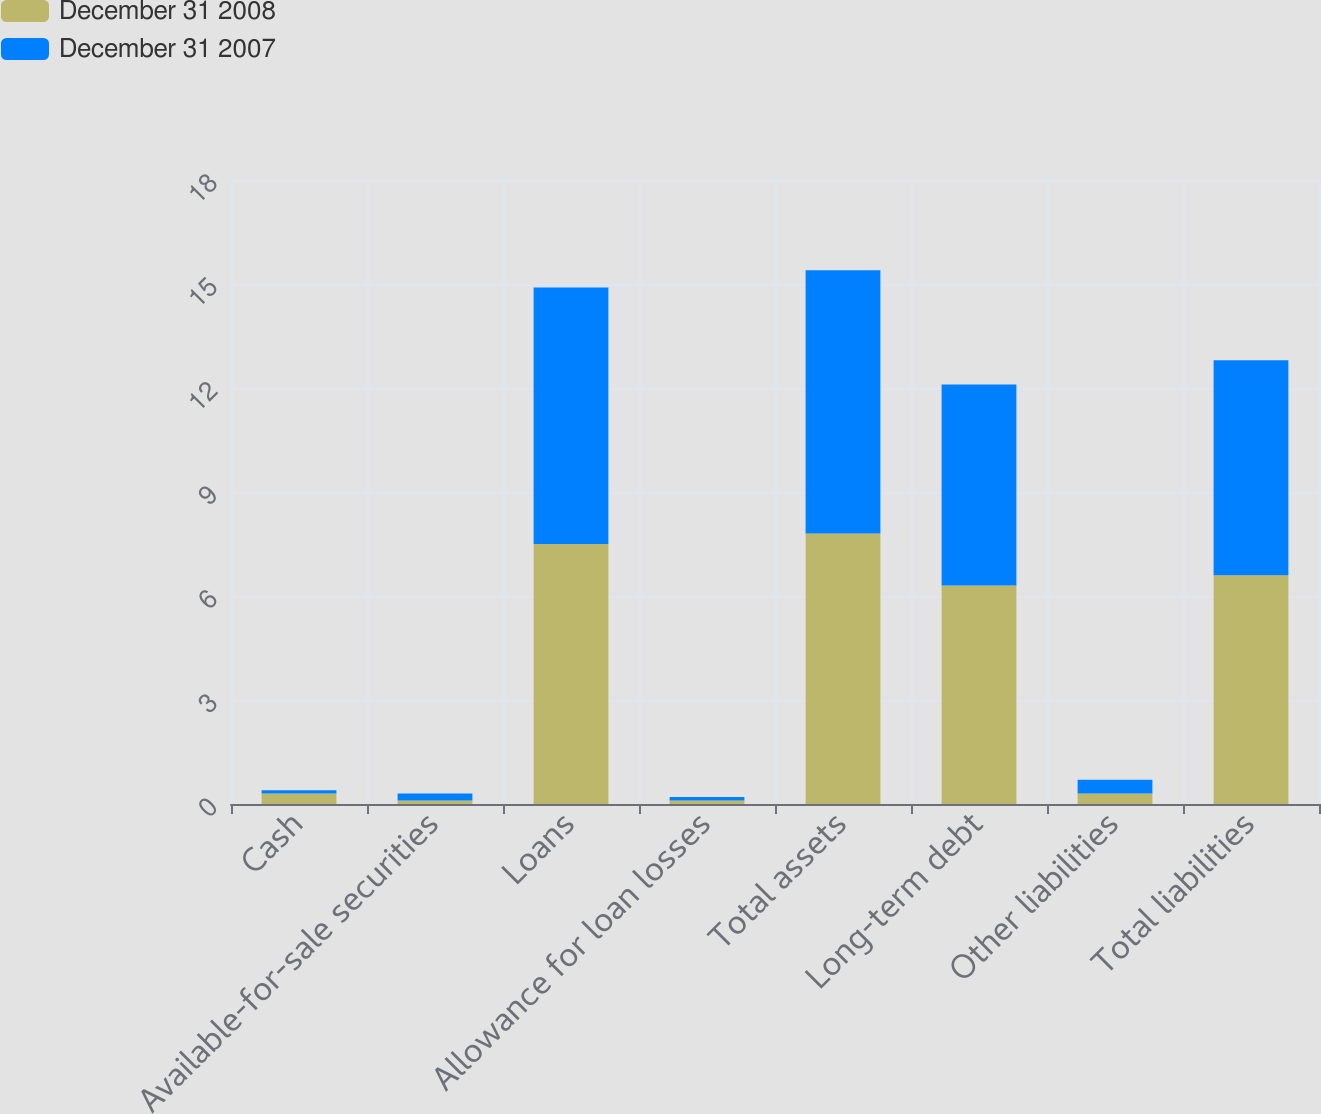Convert chart. <chart><loc_0><loc_0><loc_500><loc_500><stacked_bar_chart><ecel><fcel>Cash<fcel>Available-for-sale securities<fcel>Loans<fcel>Allowance for loan losses<fcel>Total assets<fcel>Long-term debt<fcel>Other liabilities<fcel>Total liabilities<nl><fcel>December 31 2008<fcel>0.3<fcel>0.1<fcel>7.5<fcel>0.1<fcel>7.8<fcel>6.3<fcel>0.3<fcel>6.6<nl><fcel>December 31 2007<fcel>0.1<fcel>0.2<fcel>7.4<fcel>0.1<fcel>7.6<fcel>5.8<fcel>0.4<fcel>6.2<nl></chart> 